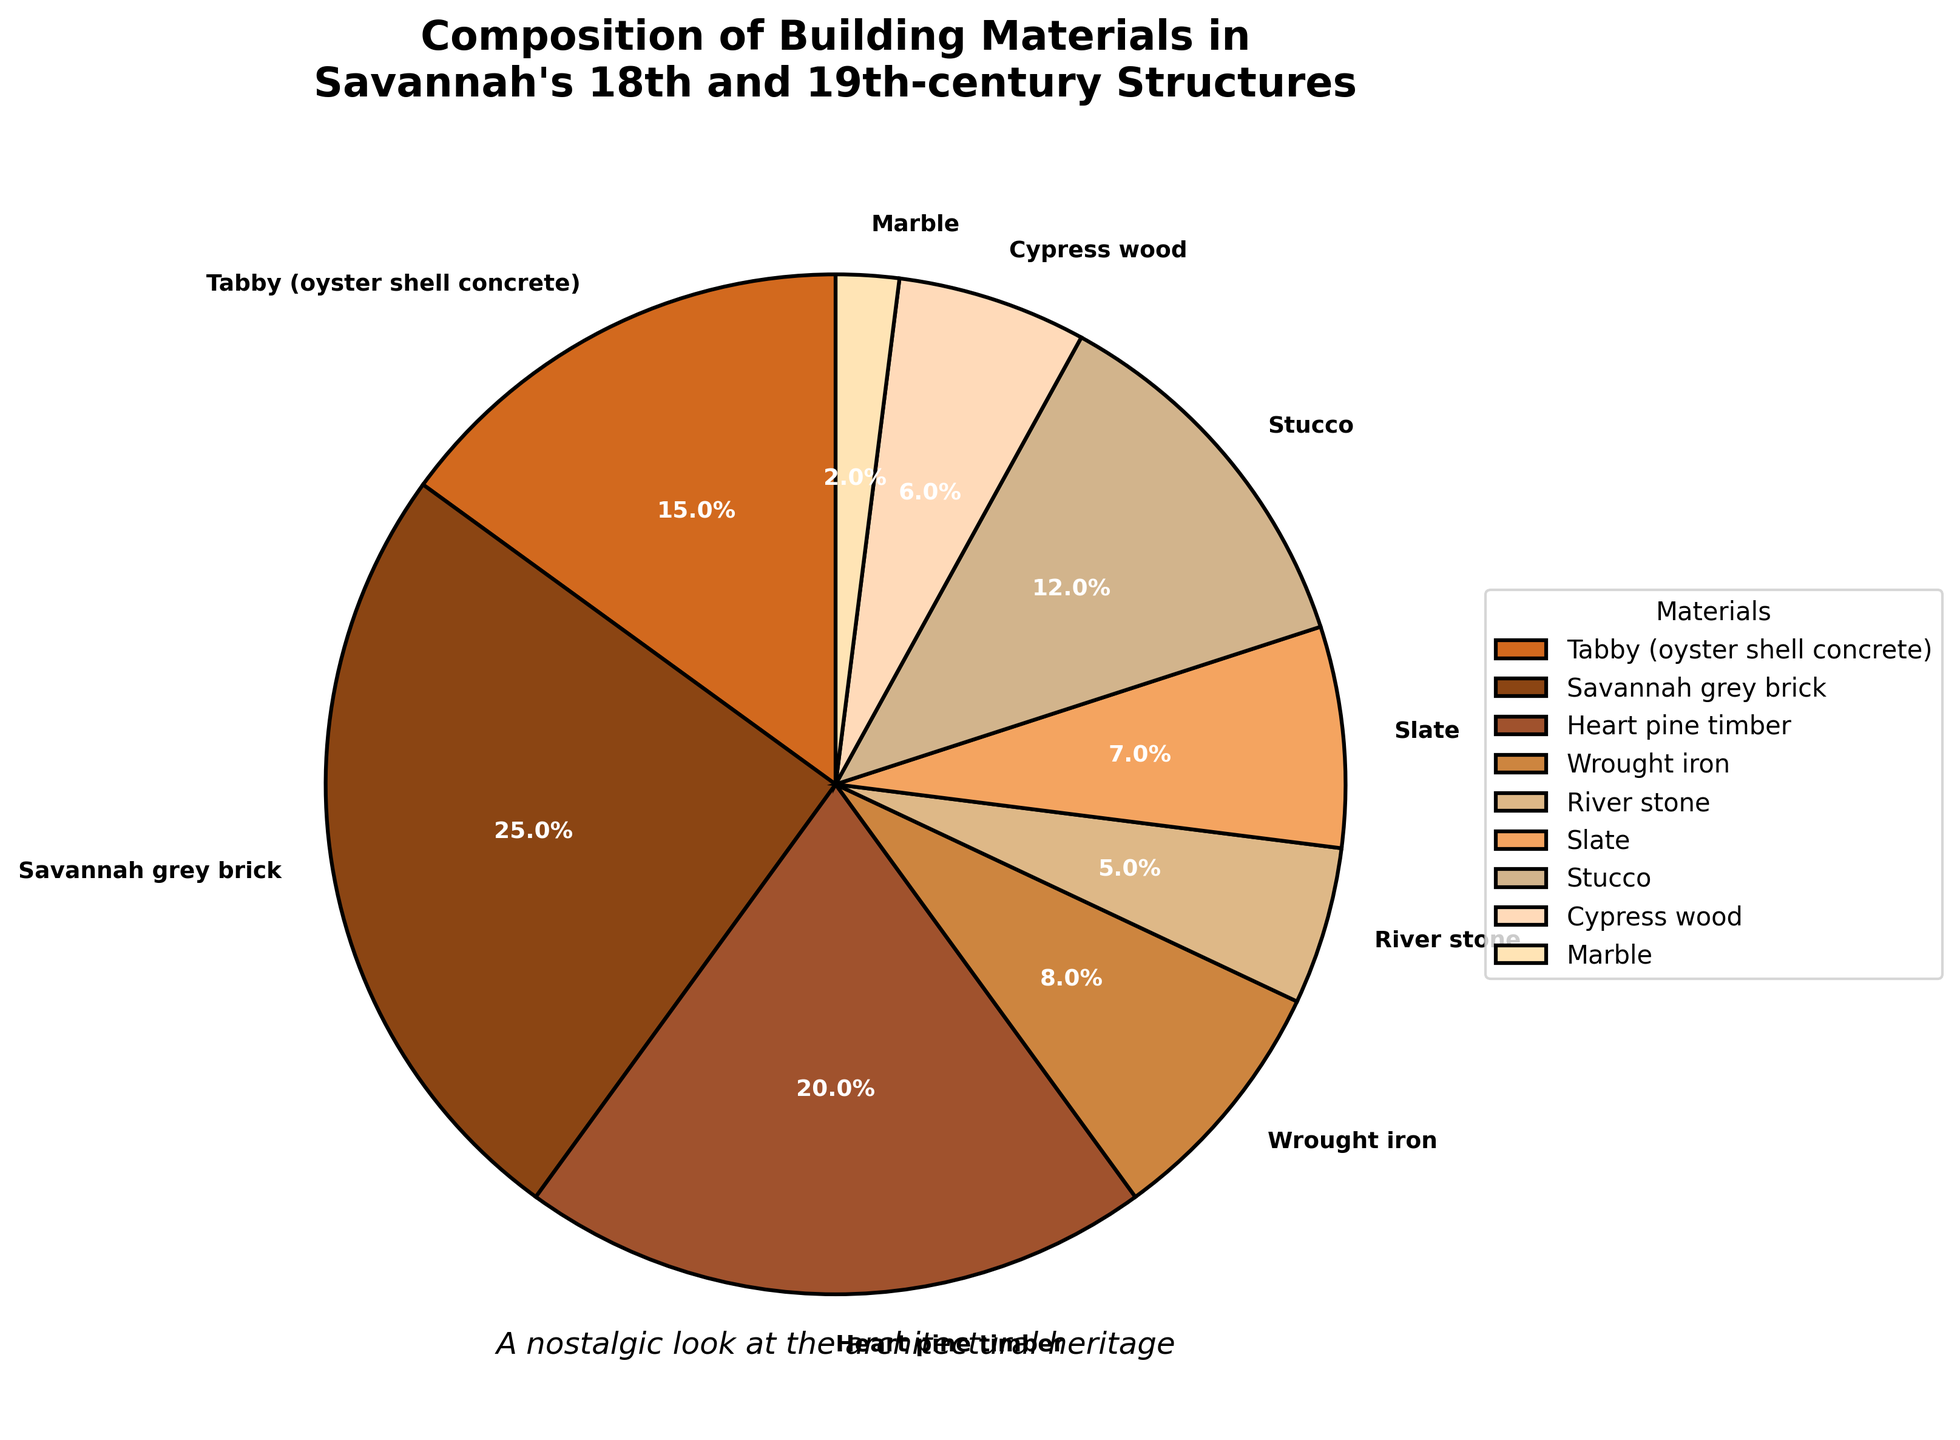Which material holds the highest percentage in the composition of Savannah's 18th and 19th-century structures? By observing the pie chart, we see that "Savannah grey brick" holds the largest segment.
Answer: Savannah grey brick What is the combined percentage of Tabby and Heart pine timber? Tabby constitutes 15%, and Heart pine timber represents 20%. Adding these gives 15% + 20% = 35%.
Answer: 35% How does the percentage of Wrought iron compare to that of Slate? Wrought iron is 8% and Slate is 7%. Wrought iron has a higher percentage than Slate.
Answer: Wrought iron > Slate Which material has the smallest representation in the pie chart? By viewing the chart, Marble has the smallest segment at 2%.
Answer: Marble How much more percentage does Savannah grey brick have compared to Cypress wood? Savannah grey brick is 25% and Cypress wood is 6%. The difference is 25% - 6% = 19%.
Answer: 19% What two materials together make up over one-third of the pie chart? Savannah grey brick is 25% and Heart pine timber is 20%. Together they are 25% + 20% = 45%, which is more than one-third (33.33%).
Answer: Savannah grey brick and Heart pine timber If you combine the percentages of Slate and Stucco, what fraction of the whole do they compose? Slate is 7% and Stucco is 12%. Added together, they are 7% + 12% = 19%. This is 19/100, which simplifies to 19%.
Answer: 19% What is the visual property (color) of the segment representing Tabby? The segment for Tabby is typically brownish-orange in color.
Answer: brownish-orange Which is more prevalent: River stone or Cypress wood? And by how much? River stone is 5%, and Cypress wood is 6%. Cypress wood is more prevalent by 6% - 5% = 1%.
Answer: Cypress wood by 1% Which material segments occupy adjacent positions on the pie chart and together represent 27%? The Slate (7%) and Stucco (12%) segments are adjacent and together account for 19%. The next adjacent pair is Wrought iron (8%) and Slate (7%), which together do not equal 27%. Thus, the pair Heart pine timber (20%) and Wrought iron (8%) add up to 28%. Thus, there is no exact match, but Heart pine timber and Wrought iron are visually adjacent and the closest at 28%.
Answer: Heart pine timber and Wrought iron (closest at 28%) 